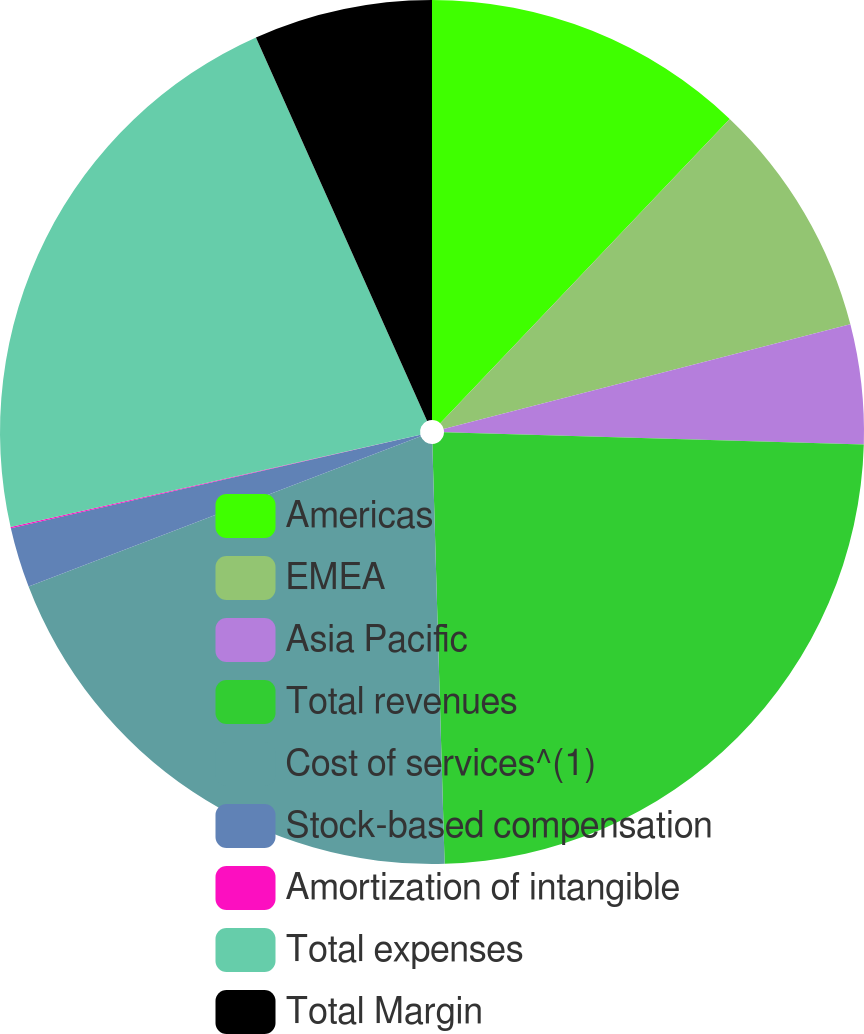Convert chart. <chart><loc_0><loc_0><loc_500><loc_500><pie_chart><fcel>Americas<fcel>EMEA<fcel>Asia Pacific<fcel>Total revenues<fcel>Cost of services^(1)<fcel>Stock-based compensation<fcel>Amortization of intangible<fcel>Total expenses<fcel>Total Margin<nl><fcel>12.1%<fcel>8.89%<fcel>4.47%<fcel>24.07%<fcel>19.64%<fcel>2.25%<fcel>0.04%<fcel>21.85%<fcel>6.68%<nl></chart> 